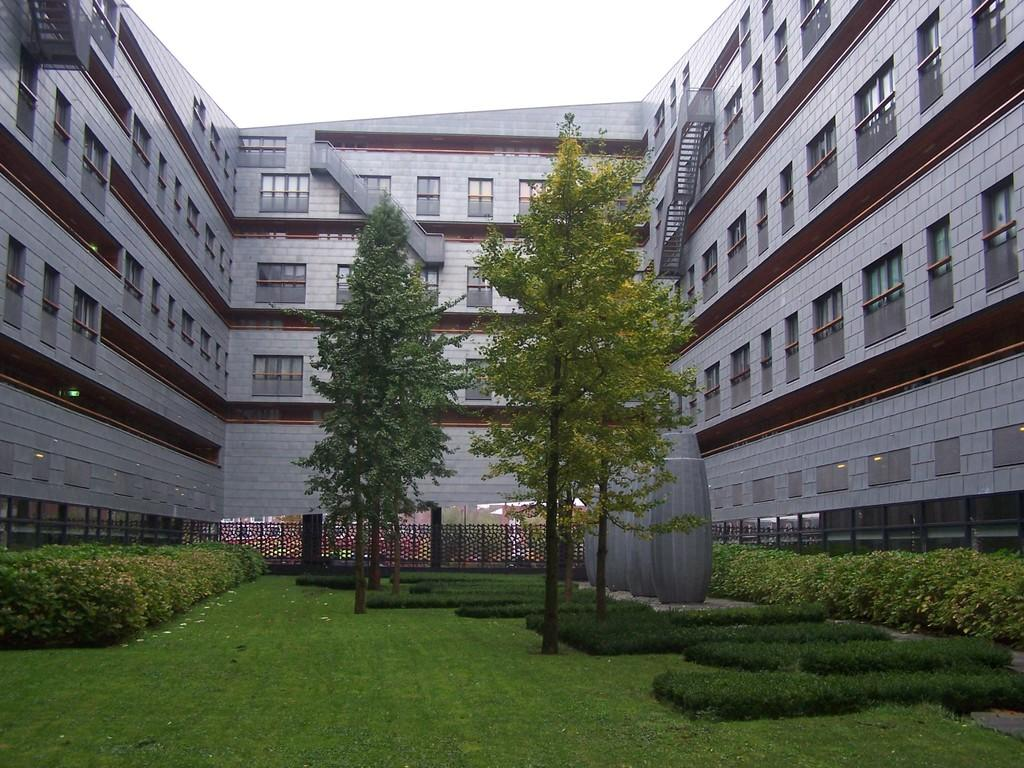What type of vegetation can be seen in the image? There are plants, many trees, and grass in the image. What is the purpose of the railing in the image? The railing's purpose is not specified in the image, but it could be for safety or decoration. What can be seen in the background of the image? There is a building with windows and the sky visible in the background of the image. Who is the owner of the yam in the image? There is no yam present in the image, so it is not possible to determine the owner. 